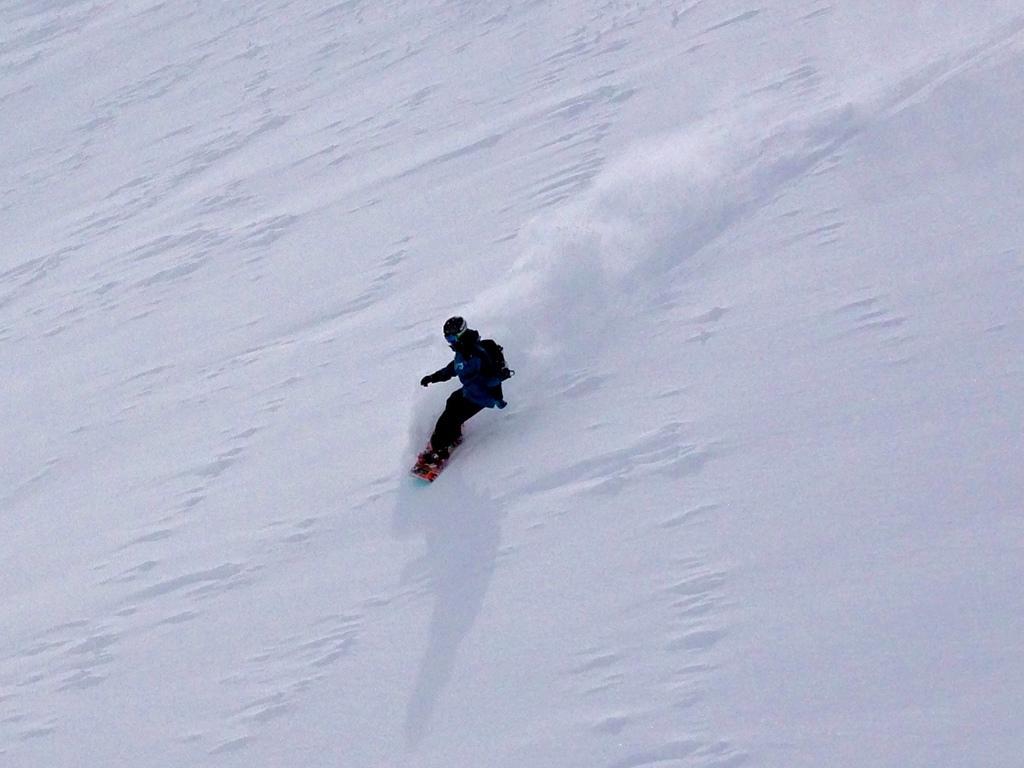Describe this image in one or two sentences. In the image we can see there is a person skiing on the ground and he is wearing jacket and helmet. The ground is covered with snow. 